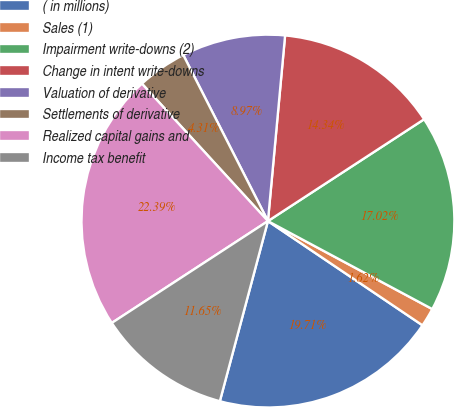Convert chart to OTSL. <chart><loc_0><loc_0><loc_500><loc_500><pie_chart><fcel>( in millions)<fcel>Sales (1)<fcel>Impairment write-downs (2)<fcel>Change in intent write-downs<fcel>Valuation of derivative<fcel>Settlements of derivative<fcel>Realized capital gains and<fcel>Income tax benefit<nl><fcel>19.71%<fcel>1.62%<fcel>17.02%<fcel>14.34%<fcel>8.97%<fcel>4.31%<fcel>22.39%<fcel>11.65%<nl></chart> 